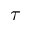<formula> <loc_0><loc_0><loc_500><loc_500>\tau</formula> 